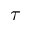<formula> <loc_0><loc_0><loc_500><loc_500>\tau</formula> 